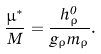<formula> <loc_0><loc_0><loc_500><loc_500>\frac { \mu ^ { * } } { M } = \frac { h _ { \rho } ^ { 0 } } { g _ { \rho } m _ { \rho } } .</formula> 